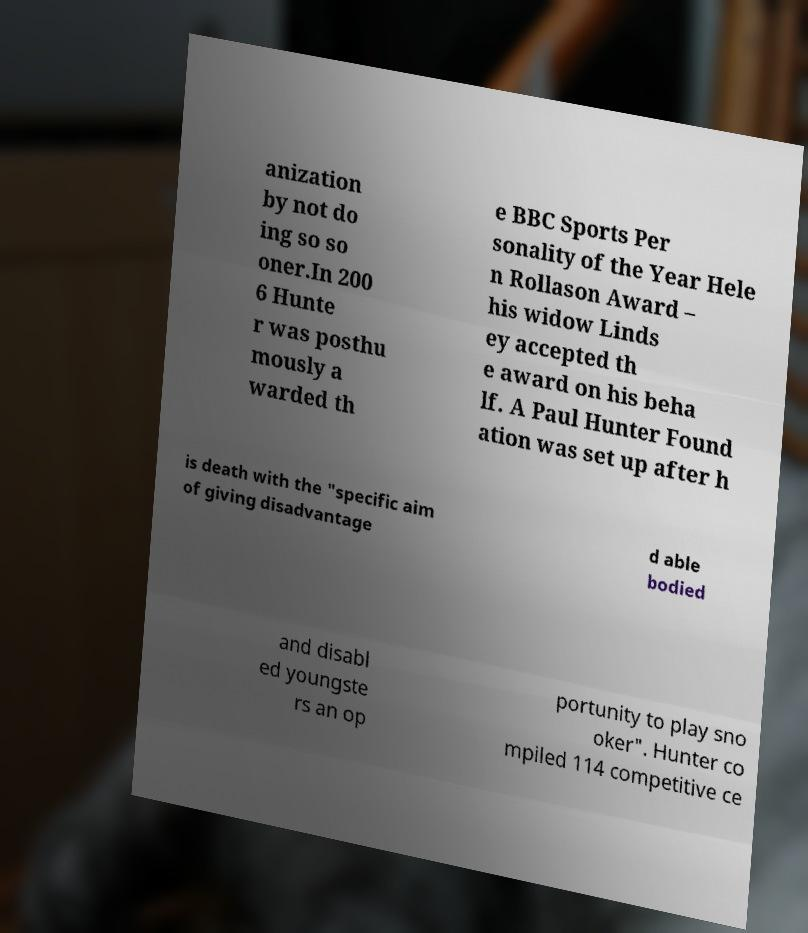There's text embedded in this image that I need extracted. Can you transcribe it verbatim? anization by not do ing so so oner.In 200 6 Hunte r was posthu mously a warded th e BBC Sports Per sonality of the Year Hele n Rollason Award – his widow Linds ey accepted th e award on his beha lf. A Paul Hunter Found ation was set up after h is death with the "specific aim of giving disadvantage d able bodied and disabl ed youngste rs an op portunity to play sno oker". Hunter co mpiled 114 competitive ce 